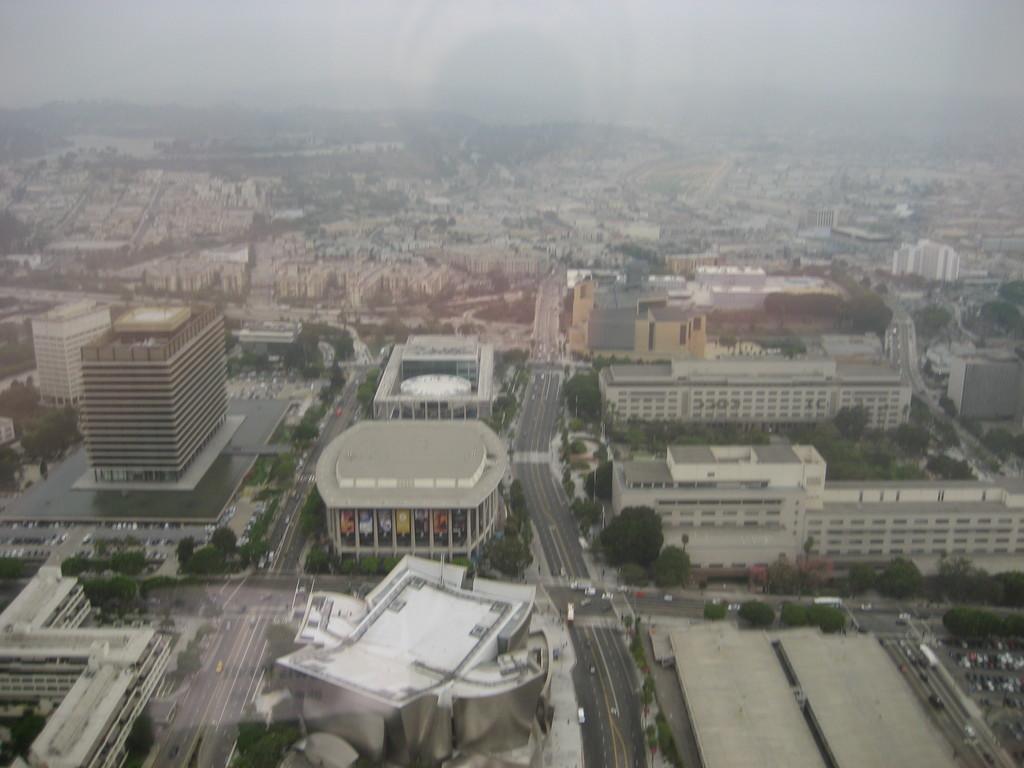Please provide a concise description of this image. This picture consists of Aerial view of the city and I can see buildings and roads and trees visible in the middle. At the top I can see the sky. 